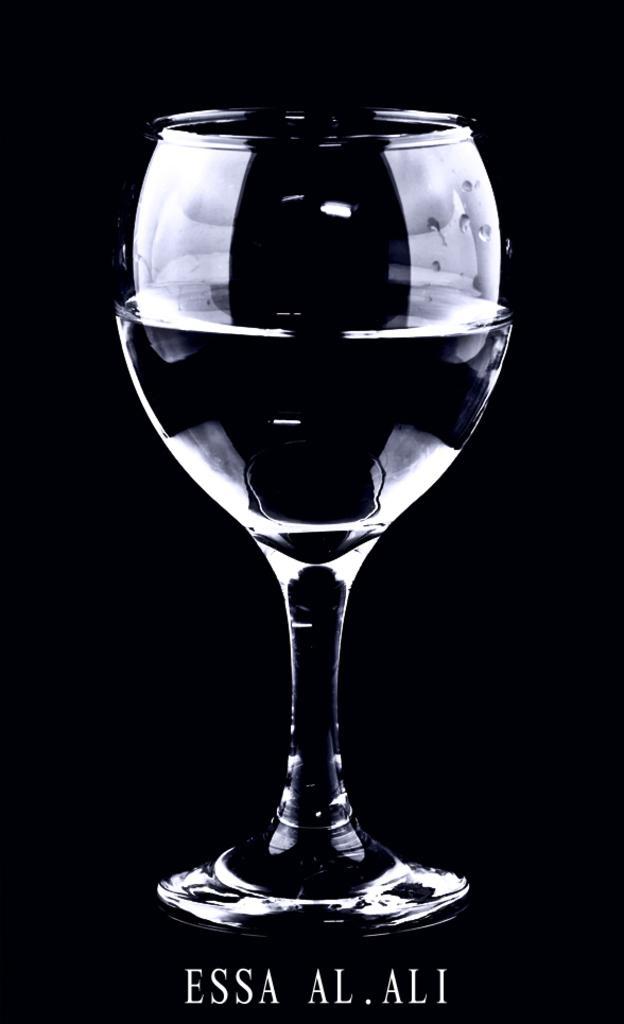Can you describe this image briefly? In this image, we can see a glass with some drink. In the background, we can see black color. At the bottom, we can see some text. 